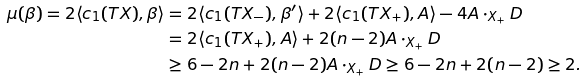<formula> <loc_0><loc_0><loc_500><loc_500>\mu ( \beta ) = 2 \langle c _ { 1 } ( T X ) , \beta \rangle & = 2 \langle c _ { 1 } ( T X _ { - } ) , \beta ^ { \prime } \rangle + 2 \langle c _ { 1 } ( T X _ { + } ) , A \rangle - 4 A \cdot _ { X _ { + } } D \\ & = 2 \langle c _ { 1 } ( T X _ { + } ) , A \rangle + 2 ( n - 2 ) A \cdot _ { X _ { + } } D \\ & \geq 6 - 2 n + 2 ( n - 2 ) A \cdot _ { X _ { + } } D \geq 6 - 2 n + 2 ( n - 2 ) \geq 2 .</formula> 